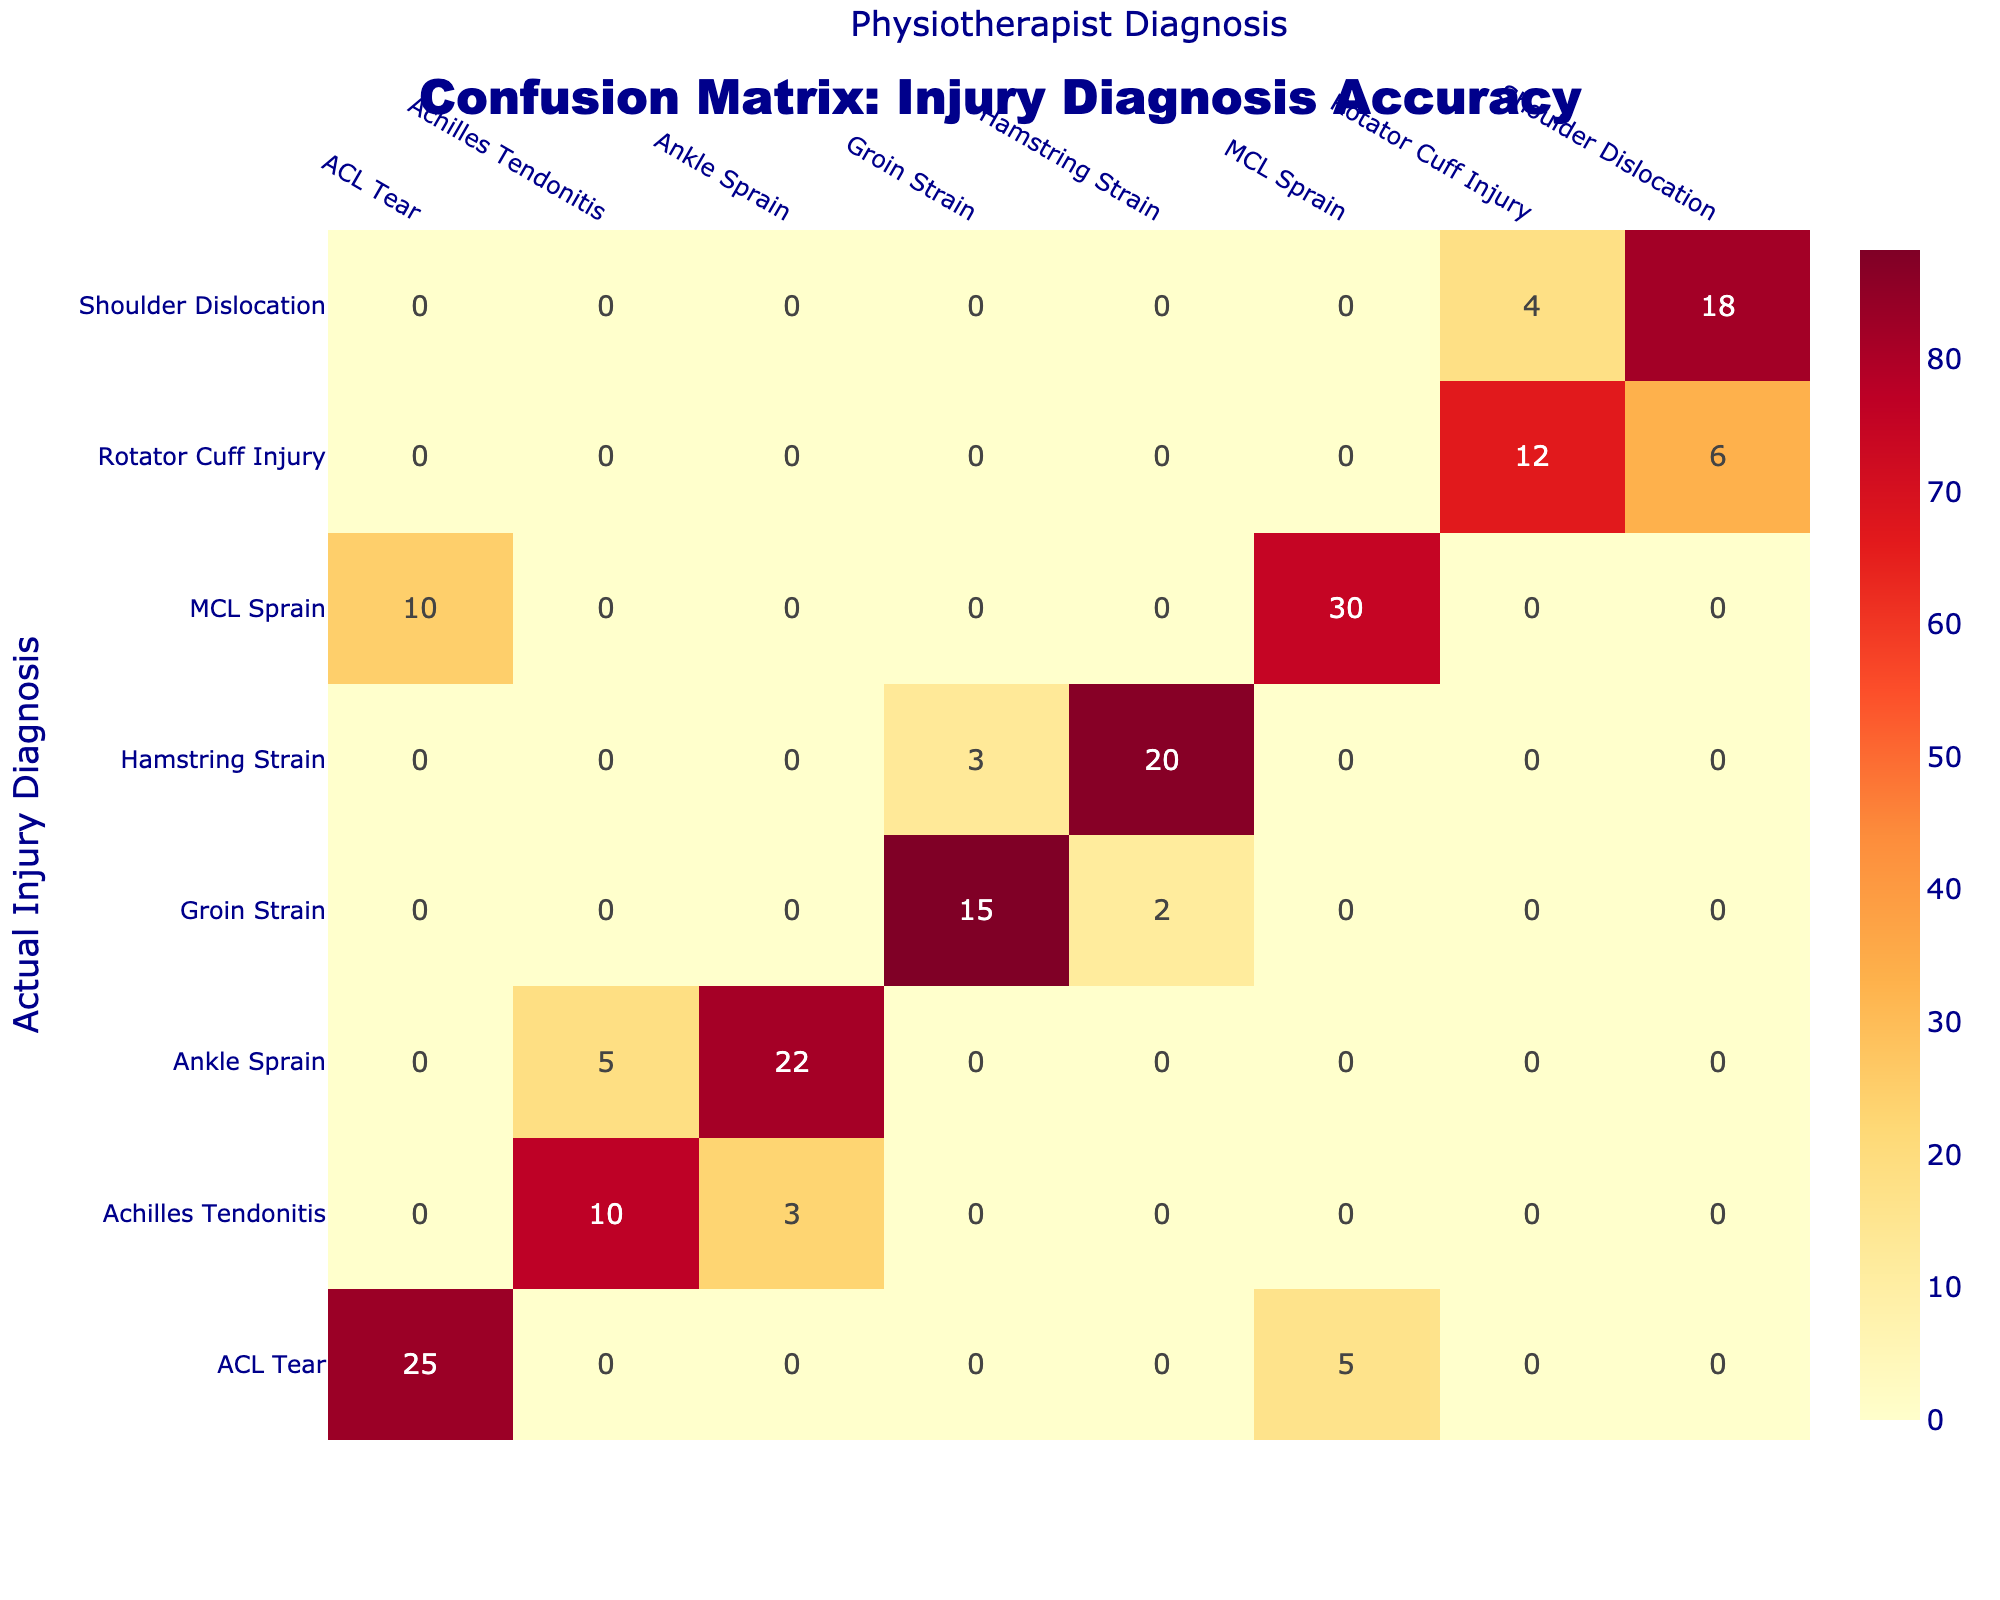What is the count of actual ACL Tear cases diagnosed correctly? The count for actual ACL Tear diagnosed correctly is found in the row for ACL Tear and the column for ACL Tear, which states 25.
Answer: 25 How many cases of MCL Sprain were misdiagnosed as ACL Tear? The count of MCL Sprain misdiagnosed as ACL Tear is located in the row for MCL Sprain and the column for ACL Tear, which states 10.
Answer: 10 What is the percentage of Hamstring Strain cases accurately diagnosed? The percentage of accurate diagnoses for Hamstring Strain is calculated as (20 correct diagnoses / (20 correct + 3 misdiagnosed as Groin Strain)) * 100 = (20 / 23) * 100 ≈ 86.96%.
Answer: 86.96% Did the physiotherapist ever misdiagnose Shoulder Dislocation as Rotator Cuff Injury? Yes, the table indicates that 4 cases of Shoulder Dislocation were misdiagnosed as Rotator Cuff Injury.
Answer: Yes What is the total count of diagnoses for Groin Strain? The total count for Groin Strain is the sum of the correctly diagnosed as Groin Strain (15) and the misdiagnosed as Hamstring Strain (2), giving us a total of 15 + 2 = 17.
Answer: 17 How many actual diagnoses of Ankle Sprain were correctly identified? The correct diagnosis of Ankle Sprain is represented by the row for Ankle Sprain and column for Ankle Sprain, which shows a count of 22.
Answer: 22 What percentage of Achilles Tendonitis cases were diagnosed incorrectly? The count of Achilles Tendonitis cases incorrectly diagnosed is 3 (Ankle Sprain) out of a total of 13 (10 correct + 3 incorrect). The percentage is (3 / 13) * 100 ≈ 23.08%.
Answer: 23.08% Which injury had the highest correct diagnosis count? By comparing the counts of correct diagnoses across all injuries, ACL Tear has the highest count at 25.
Answer: ACL Tear What is the total number of injuries classified as Shoulder Dislocation? To find the total, we add the correctly diagnosed (18) and the misdiagnosed (4 as Rotator Cuff Injury), resulting in a total of 18 + 4 = 22.
Answer: 22 